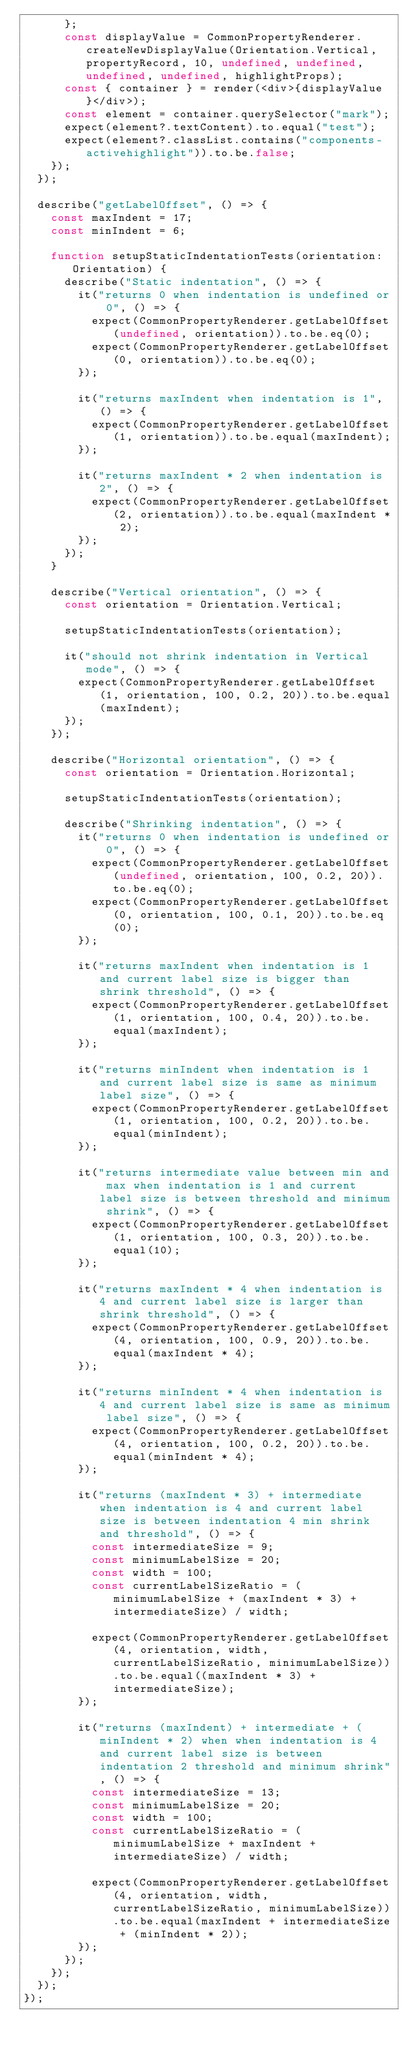<code> <loc_0><loc_0><loc_500><loc_500><_TypeScript_>      };
      const displayValue = CommonPropertyRenderer.createNewDisplayValue(Orientation.Vertical, propertyRecord, 10, undefined, undefined, undefined, undefined, highlightProps);
      const { container } = render(<div>{displayValue}</div>);
      const element = container.querySelector("mark");
      expect(element?.textContent).to.equal("test");
      expect(element?.classList.contains("components-activehighlight")).to.be.false;
    });
  });

  describe("getLabelOffset", () => {
    const maxIndent = 17;
    const minIndent = 6;

    function setupStaticIndentationTests(orientation: Orientation) {
      describe("Static indentation", () => {
        it("returns 0 when indentation is undefined or 0", () => {
          expect(CommonPropertyRenderer.getLabelOffset(undefined, orientation)).to.be.eq(0);
          expect(CommonPropertyRenderer.getLabelOffset(0, orientation)).to.be.eq(0);
        });

        it("returns maxIndent when indentation is 1", () => {
          expect(CommonPropertyRenderer.getLabelOffset(1, orientation)).to.be.equal(maxIndent);
        });

        it("returns maxIndent * 2 when indentation is 2", () => {
          expect(CommonPropertyRenderer.getLabelOffset(2, orientation)).to.be.equal(maxIndent * 2);
        });
      });
    }

    describe("Vertical orientation", () => {
      const orientation = Orientation.Vertical;

      setupStaticIndentationTests(orientation);

      it("should not shrink indentation in Vertical mode", () => {
        expect(CommonPropertyRenderer.getLabelOffset(1, orientation, 100, 0.2, 20)).to.be.equal(maxIndent);
      });
    });

    describe("Horizontal orientation", () => {
      const orientation = Orientation.Horizontal;

      setupStaticIndentationTests(orientation);

      describe("Shrinking indentation", () => {
        it("returns 0 when indentation is undefined or 0", () => {
          expect(CommonPropertyRenderer.getLabelOffset(undefined, orientation, 100, 0.2, 20)).to.be.eq(0);
          expect(CommonPropertyRenderer.getLabelOffset(0, orientation, 100, 0.1, 20)).to.be.eq(0);
        });

        it("returns maxIndent when indentation is 1 and current label size is bigger than shrink threshold", () => {
          expect(CommonPropertyRenderer.getLabelOffset(1, orientation, 100, 0.4, 20)).to.be.equal(maxIndent);
        });

        it("returns minIndent when indentation is 1 and current label size is same as minimum label size", () => {
          expect(CommonPropertyRenderer.getLabelOffset(1, orientation, 100, 0.2, 20)).to.be.equal(minIndent);
        });

        it("returns intermediate value between min and max when indentation is 1 and current label size is between threshold and minimum shrink", () => {
          expect(CommonPropertyRenderer.getLabelOffset(1, orientation, 100, 0.3, 20)).to.be.equal(10);
        });

        it("returns maxIndent * 4 when indentation is 4 and current label size is larger than shrink threshold", () => {
          expect(CommonPropertyRenderer.getLabelOffset(4, orientation, 100, 0.9, 20)).to.be.equal(maxIndent * 4);
        });

        it("returns minIndent * 4 when indentation is 4 and current label size is same as minimum label size", () => {
          expect(CommonPropertyRenderer.getLabelOffset(4, orientation, 100, 0.2, 20)).to.be.equal(minIndent * 4);
        });

        it("returns (maxIndent * 3) + intermediate when indentation is 4 and current label size is between indentation 4 min shrink and threshold", () => {
          const intermediateSize = 9;
          const minimumLabelSize = 20;
          const width = 100;
          const currentLabelSizeRatio = (minimumLabelSize + (maxIndent * 3) + intermediateSize) / width;

          expect(CommonPropertyRenderer.getLabelOffset(4, orientation, width, currentLabelSizeRatio, minimumLabelSize)).to.be.equal((maxIndent * 3) + intermediateSize);
        });

        it("returns (maxIndent) + intermediate + (minIndent * 2) when when indentation is 4 and current label size is between indentation 2 threshold and minimum shrink", () => {
          const intermediateSize = 13;
          const minimumLabelSize = 20;
          const width = 100;
          const currentLabelSizeRatio = (minimumLabelSize + maxIndent + intermediateSize) / width;

          expect(CommonPropertyRenderer.getLabelOffset(4, orientation, width, currentLabelSizeRatio, minimumLabelSize)).to.be.equal(maxIndent + intermediateSize + (minIndent * 2));
        });
      });
    });
  });
});
</code> 